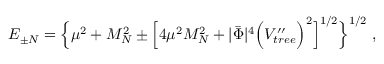Convert formula to latex. <formula><loc_0><loc_0><loc_500><loc_500>E _ { \pm N } = \left \{ \mu ^ { 2 } + M _ { N } ^ { 2 } \pm \left [ 4 \mu ^ { 2 } M _ { N } ^ { 2 } + | \bar { \Phi } | ^ { 4 } \left ( V _ { t r e e } ^ { \prime \prime } \right ) ^ { 2 } \right ] ^ { 1 / 2 } \right \} ^ { 1 / 2 } \, ,</formula> 